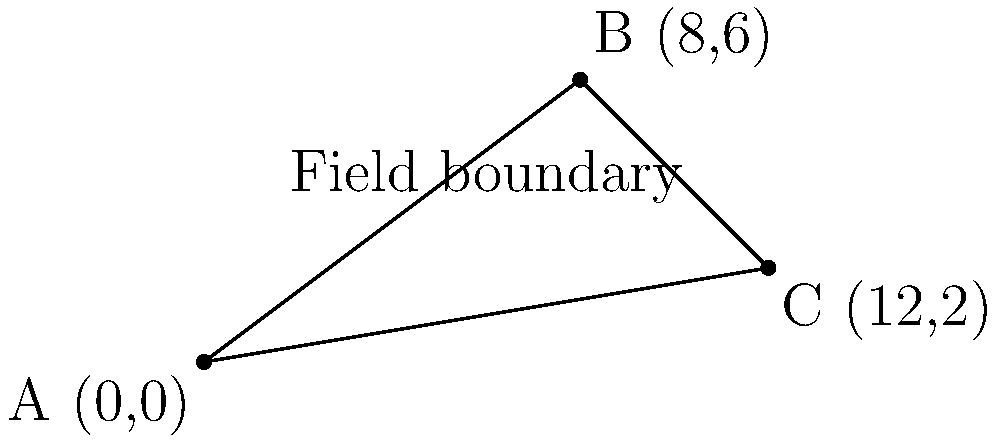As a farmer using modern agricultural techniques, you need to determine the most efficient path for your farm equipment. Your field is represented by a triangle with vertices at A(0,0), B(8,6), and C(12,2). Which path is shorter: going directly from A to C, or going from A to B and then to C? Calculate the difference in distance between these two paths to the nearest tenth of a unit. To solve this problem, we'll use the distance formula between two points: $d = \sqrt{(x_2-x_1)^2 + (y_2-y_1)^2}$

1. Calculate the distance from A to C (direct path):
   $AC = \sqrt{(12-0)^2 + (2-0)^2} = \sqrt{144 + 4} = \sqrt{148} \approx 12.17$ units

2. Calculate the distance from A to B:
   $AB = \sqrt{(8-0)^2 + (6-0)^2} = \sqrt{64 + 36} = \sqrt{100} = 10$ units

3. Calculate the distance from B to C:
   $BC = \sqrt{(12-8)^2 + (2-6)^2} = \sqrt{16 + 16} = \sqrt{32} \approx 5.66$ units

4. Calculate the total distance of path A to B to C:
   $AB + BC = 10 + 5.66 = 15.66$ units

5. Calculate the difference between the two paths:
   $15.66 - 12.17 = 3.49$ units

Rounding to the nearest tenth: 3.5 units

Therefore, the direct path from A to C is shorter by approximately 3.5 units.
Answer: 3.5 units 